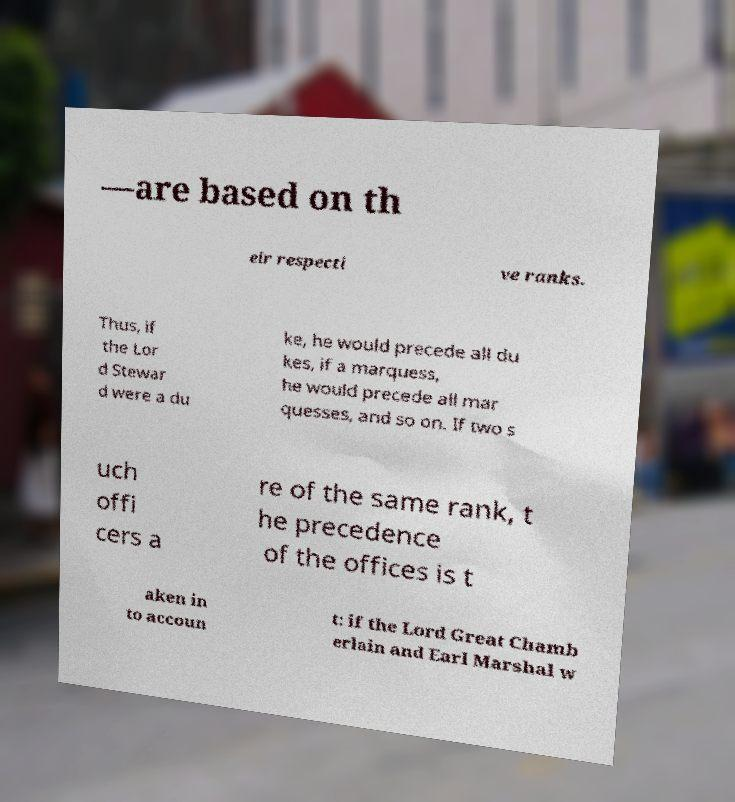Can you read and provide the text displayed in the image?This photo seems to have some interesting text. Can you extract and type it out for me? —are based on th eir respecti ve ranks. Thus, if the Lor d Stewar d were a du ke, he would precede all du kes, if a marquess, he would precede all mar quesses, and so on. If two s uch offi cers a re of the same rank, t he precedence of the offices is t aken in to accoun t: if the Lord Great Chamb erlain and Earl Marshal w 